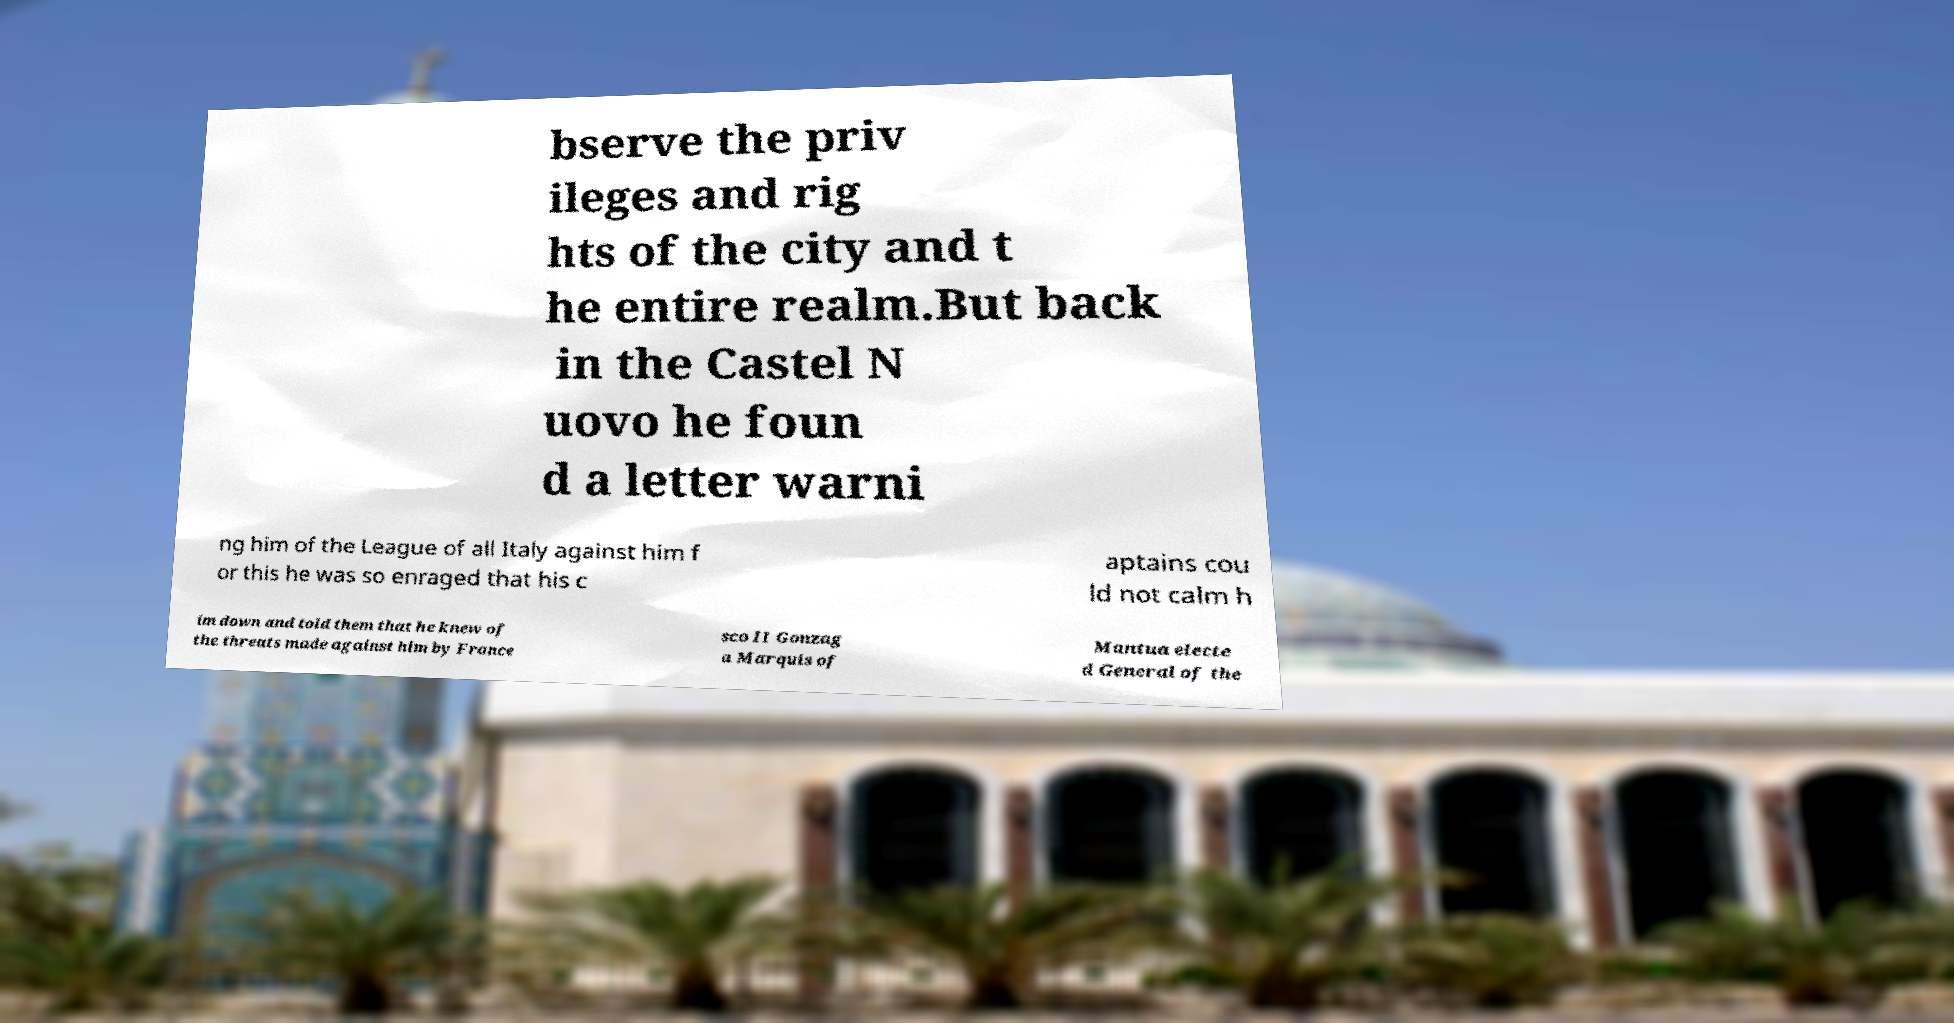Please identify and transcribe the text found in this image. bserve the priv ileges and rig hts of the city and t he entire realm.But back in the Castel N uovo he foun d a letter warni ng him of the League of all Italy against him f or this he was so enraged that his c aptains cou ld not calm h im down and told them that he knew of the threats made against him by France sco II Gonzag a Marquis of Mantua electe d General of the 